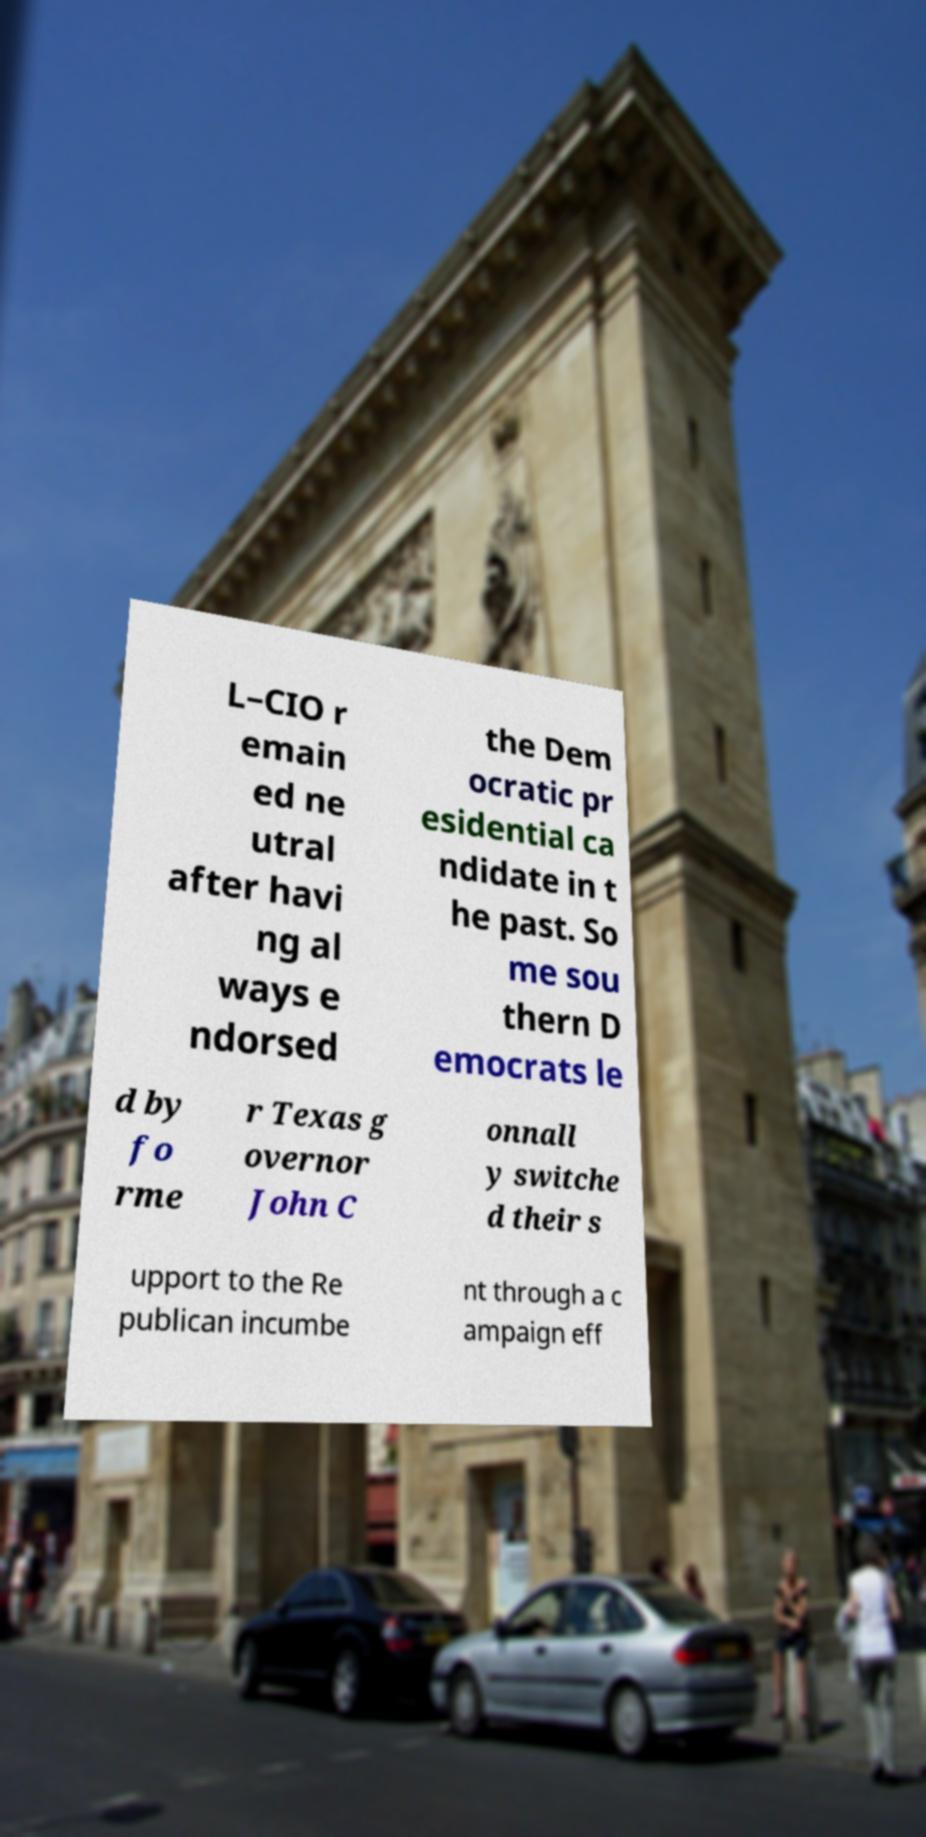I need the written content from this picture converted into text. Can you do that? L–CIO r emain ed ne utral after havi ng al ways e ndorsed the Dem ocratic pr esidential ca ndidate in t he past. So me sou thern D emocrats le d by fo rme r Texas g overnor John C onnall y switche d their s upport to the Re publican incumbe nt through a c ampaign eff 